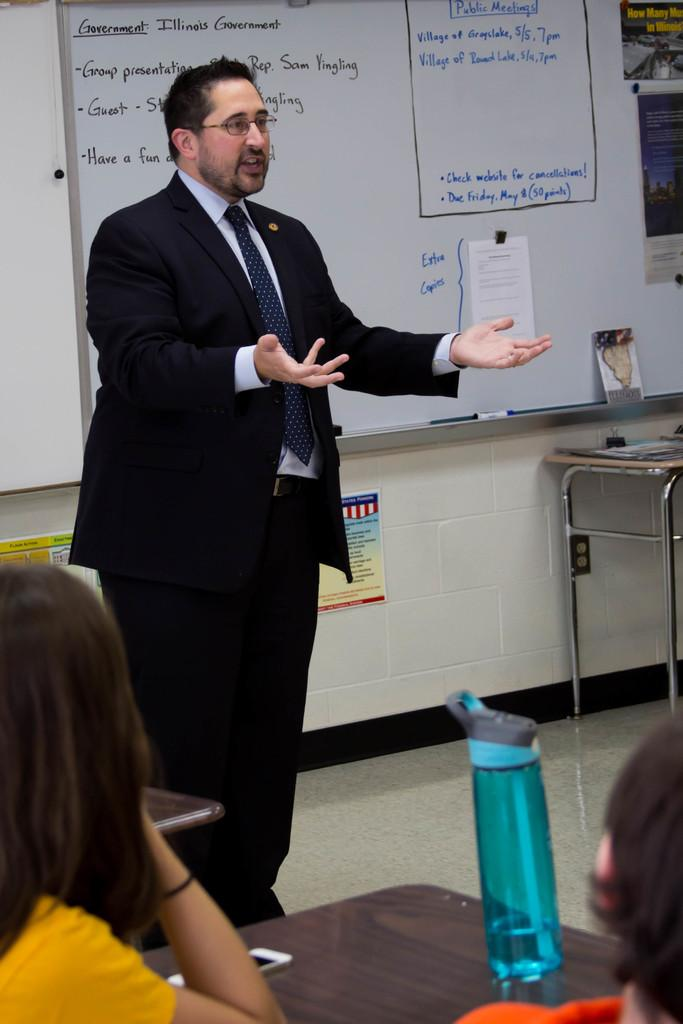<image>
Present a compact description of the photo's key features. A man talking to students with extra copies of homework on the board. 